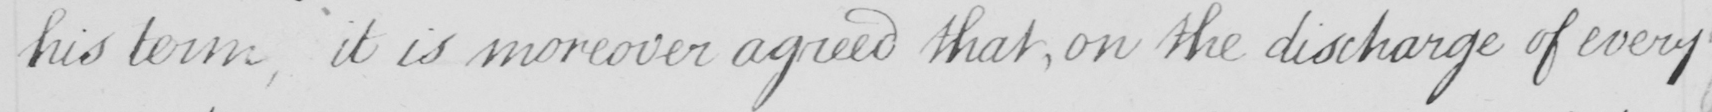Can you read and transcribe this handwriting? his term , it is moreover agreed that , on the discharge of every 